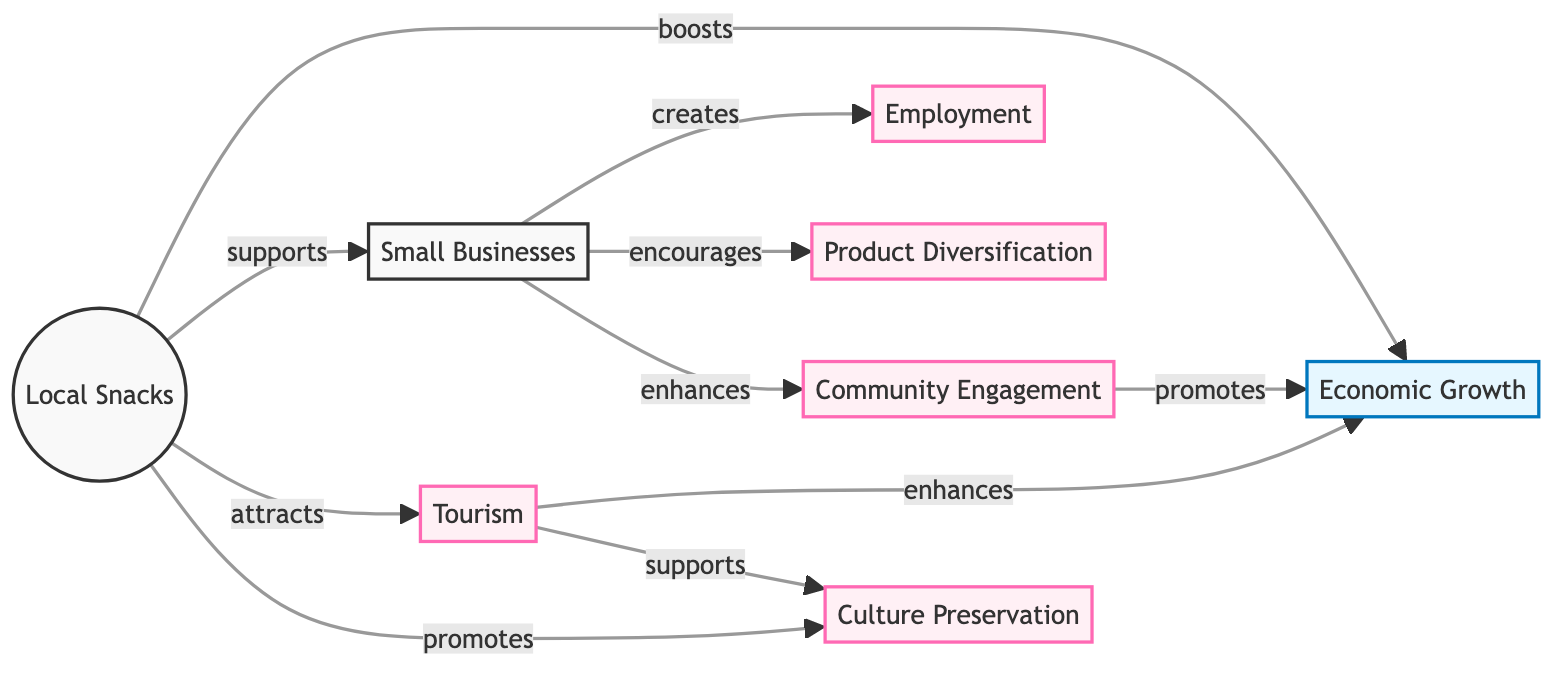What is the main subject of the diagram? The diagram centers around "Local Snacks," depicted as the starting point from which various impacts and effects branch.
Answer: Local Snacks How many nodes are related to small businesses? The diagram shows that "small businesses" is connected to three nodes: "employment," "product diversification," and "community engagement." By counting these edges, we determine the number of connected nodes.
Answer: 3 What impact do local snacks have on tourism? The diagram indicates that local snacks "attract" tourism, which then "enhances" economic growth. This relationship demonstrates how local snacks contribute to tourism.
Answer: Attracts What effect does community engagement have? According to the diagram, "community engagement" promotes "economic growth," suggesting a direct positive effect on the economic cycle.
Answer: Promotes Which factor directly links small businesses to economic growth? The diagram shows that "small businesses" contribute to "employment," while community engagement also enhances economic growth, thus making it a compound flow.
Answer: Employment How do local snacks promote culture preservation? The diagram illustrates that local snacks both "promote" culture preservation directly and are supported by tourism, indicating a dual pathway that enhances cultural aspects.
Answer: Promote What is the role of tourism in economic growth? The diagram specifies that tourism "enhances" economic growth, clearly illustrating its supportive role in broader economic development connected to local snacks.
Answer: Enhances What are the two outcomes resulting from economic growth in the context of this diagram? Upon analyzing the connections, "employment" and "community engagement" are identified as the two direct outcomes stemming from "economic growth" and associated links.
Answer: Employment, Community Engagement What connection exists between local snacks and product diversification? The diagram highlights that "small businesses" encourage product diversification as a direct result of local snacks, showcasing their intertwined role in fostering business variety.
Answer: Encourages How many total impacts are linked to local snacks? The diagram illustrates that local snacks are associated with five impacts, including economic growth, small businesses, tourism, culture preservation, and community engagement, when counted from the flow.
Answer: 5 